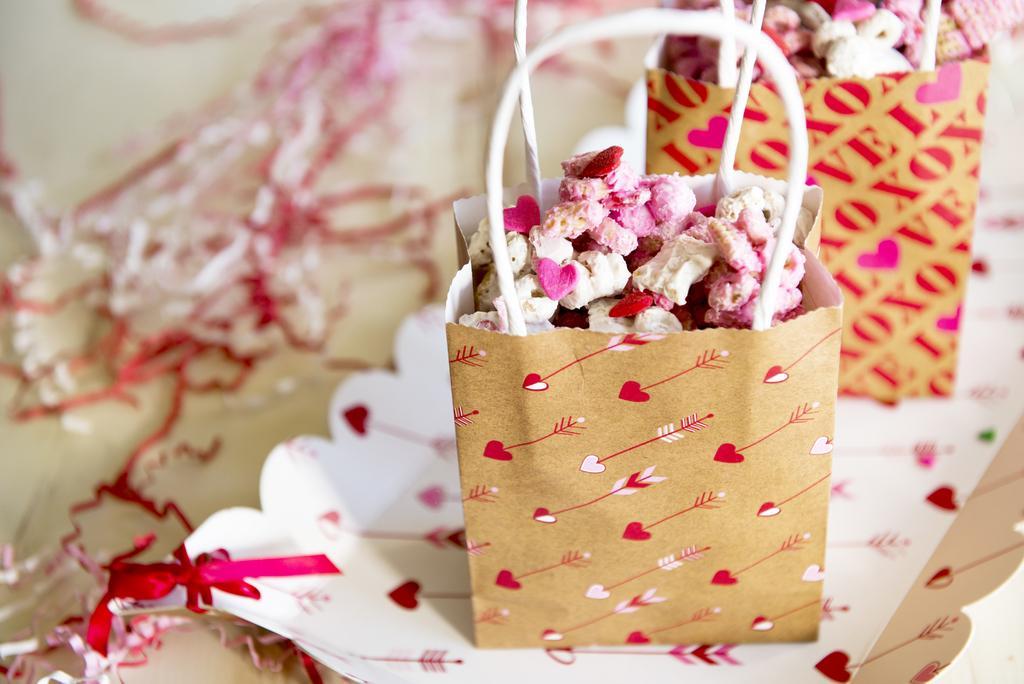Describe this image in one or two sentences. In this picture there are objects in the bags and at the bottom there are decorative papers. 